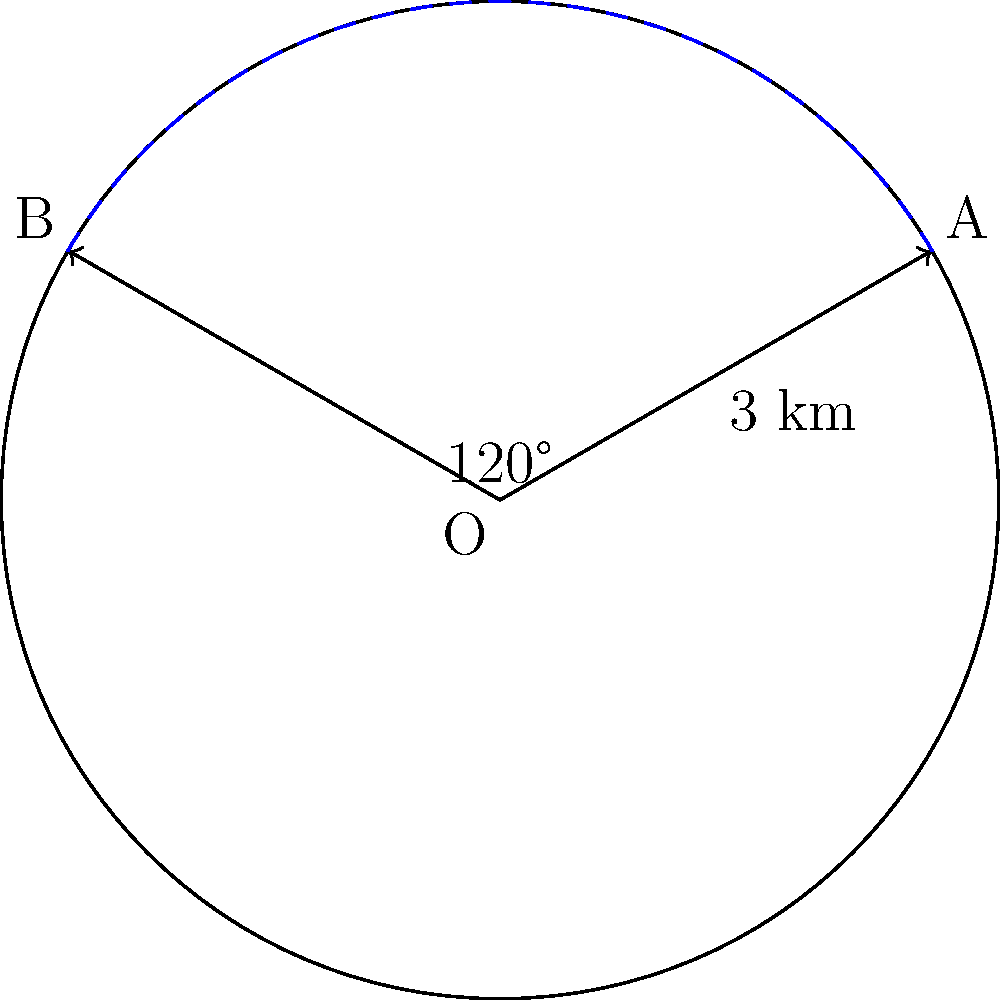You're preparing for your first rally on a circular track with a radius of 3 km. Two checkpoints, A and B, are located on the track. The angle between OA and OB is 120°, where O is the center of the track. Calculate the distance between checkpoints A and B along the track's circumference. Let's approach this step-by-step:

1) First, recall the formula for the arc length of a circle:
   $s = r\theta$
   where $s$ is the arc length, $r$ is the radius, and $\theta$ is the angle in radians.

2) We're given the angle in degrees (120°). Convert it to radians:
   $\theta = 120° \times \frac{\pi}{180°} = \frac{2\pi}{3}$ radians

3) Now we can substitute the values into the formula:
   $s = r\theta = 3 \times \frac{2\pi}{3} = 2\pi$ km

4) To get the final answer in kilometers, let's calculate:
   $s = 2\pi \approx 6.28$ km

Therefore, the distance between checkpoints A and B along the track is approximately 6.28 km.
Answer: $6.28$ km 